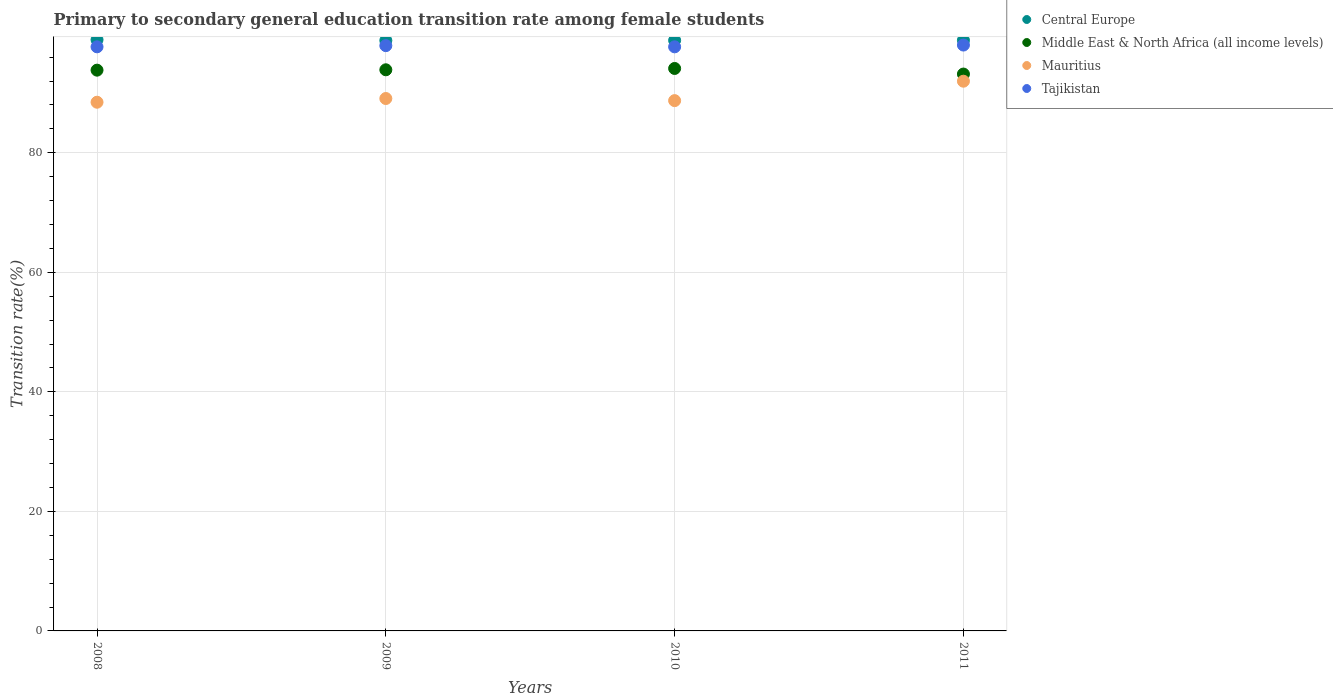How many different coloured dotlines are there?
Offer a terse response. 4. What is the transition rate in Central Europe in 2011?
Your answer should be very brief. 98.82. Across all years, what is the maximum transition rate in Middle East & North Africa (all income levels)?
Keep it short and to the point. 94.11. Across all years, what is the minimum transition rate in Tajikistan?
Offer a very short reply. 97.72. What is the total transition rate in Tajikistan in the graph?
Offer a terse response. 391.4. What is the difference between the transition rate in Tajikistan in 2008 and that in 2011?
Offer a very short reply. -0.3. What is the difference between the transition rate in Central Europe in 2009 and the transition rate in Mauritius in 2008?
Make the answer very short. 10.33. What is the average transition rate in Tajikistan per year?
Your answer should be very brief. 97.85. In the year 2008, what is the difference between the transition rate in Central Europe and transition rate in Tajikistan?
Make the answer very short. 1.19. What is the ratio of the transition rate in Middle East & North Africa (all income levels) in 2010 to that in 2011?
Keep it short and to the point. 1.01. What is the difference between the highest and the second highest transition rate in Tajikistan?
Make the answer very short. 0.1. What is the difference between the highest and the lowest transition rate in Central Europe?
Keep it short and to the point. 0.13. Does the transition rate in Mauritius monotonically increase over the years?
Give a very brief answer. No. Does the graph contain grids?
Ensure brevity in your answer.  Yes. Where does the legend appear in the graph?
Provide a succinct answer. Top right. How many legend labels are there?
Give a very brief answer. 4. What is the title of the graph?
Make the answer very short. Primary to secondary general education transition rate among female students. Does "Libya" appear as one of the legend labels in the graph?
Your answer should be very brief. No. What is the label or title of the Y-axis?
Ensure brevity in your answer.  Transition rate(%). What is the Transition rate(%) of Central Europe in 2008?
Make the answer very short. 98.92. What is the Transition rate(%) of Middle East & North Africa (all income levels) in 2008?
Your response must be concise. 93.82. What is the Transition rate(%) in Mauritius in 2008?
Offer a very short reply. 88.46. What is the Transition rate(%) of Tajikistan in 2008?
Your answer should be compact. 97.73. What is the Transition rate(%) of Central Europe in 2009?
Ensure brevity in your answer.  98.78. What is the Transition rate(%) in Middle East & North Africa (all income levels) in 2009?
Offer a very short reply. 93.88. What is the Transition rate(%) of Mauritius in 2009?
Provide a short and direct response. 89.08. What is the Transition rate(%) of Tajikistan in 2009?
Ensure brevity in your answer.  97.92. What is the Transition rate(%) of Central Europe in 2010?
Offer a very short reply. 98.81. What is the Transition rate(%) of Middle East & North Africa (all income levels) in 2010?
Ensure brevity in your answer.  94.11. What is the Transition rate(%) in Mauritius in 2010?
Your answer should be very brief. 88.72. What is the Transition rate(%) of Tajikistan in 2010?
Make the answer very short. 97.72. What is the Transition rate(%) of Central Europe in 2011?
Your answer should be compact. 98.82. What is the Transition rate(%) in Middle East & North Africa (all income levels) in 2011?
Keep it short and to the point. 93.17. What is the Transition rate(%) of Mauritius in 2011?
Offer a very short reply. 91.97. What is the Transition rate(%) of Tajikistan in 2011?
Your answer should be very brief. 98.02. Across all years, what is the maximum Transition rate(%) of Central Europe?
Offer a very short reply. 98.92. Across all years, what is the maximum Transition rate(%) in Middle East & North Africa (all income levels)?
Your answer should be compact. 94.11. Across all years, what is the maximum Transition rate(%) in Mauritius?
Ensure brevity in your answer.  91.97. Across all years, what is the maximum Transition rate(%) of Tajikistan?
Ensure brevity in your answer.  98.02. Across all years, what is the minimum Transition rate(%) in Central Europe?
Your response must be concise. 98.78. Across all years, what is the minimum Transition rate(%) in Middle East & North Africa (all income levels)?
Make the answer very short. 93.17. Across all years, what is the minimum Transition rate(%) in Mauritius?
Offer a very short reply. 88.46. Across all years, what is the minimum Transition rate(%) of Tajikistan?
Offer a very short reply. 97.72. What is the total Transition rate(%) of Central Europe in the graph?
Keep it short and to the point. 395.33. What is the total Transition rate(%) of Middle East & North Africa (all income levels) in the graph?
Your answer should be compact. 374.98. What is the total Transition rate(%) of Mauritius in the graph?
Offer a terse response. 358.24. What is the total Transition rate(%) of Tajikistan in the graph?
Offer a very short reply. 391.4. What is the difference between the Transition rate(%) in Central Europe in 2008 and that in 2009?
Provide a succinct answer. 0.13. What is the difference between the Transition rate(%) of Middle East & North Africa (all income levels) in 2008 and that in 2009?
Offer a terse response. -0.06. What is the difference between the Transition rate(%) in Mauritius in 2008 and that in 2009?
Ensure brevity in your answer.  -0.62. What is the difference between the Transition rate(%) of Tajikistan in 2008 and that in 2009?
Ensure brevity in your answer.  -0.2. What is the difference between the Transition rate(%) of Central Europe in 2008 and that in 2010?
Offer a very short reply. 0.11. What is the difference between the Transition rate(%) of Middle East & North Africa (all income levels) in 2008 and that in 2010?
Your answer should be very brief. -0.28. What is the difference between the Transition rate(%) in Mauritius in 2008 and that in 2010?
Your response must be concise. -0.27. What is the difference between the Transition rate(%) of Tajikistan in 2008 and that in 2010?
Keep it short and to the point. 0. What is the difference between the Transition rate(%) of Central Europe in 2008 and that in 2011?
Your answer should be compact. 0.09. What is the difference between the Transition rate(%) of Middle East & North Africa (all income levels) in 2008 and that in 2011?
Your answer should be compact. 0.65. What is the difference between the Transition rate(%) of Mauritius in 2008 and that in 2011?
Your answer should be very brief. -3.52. What is the difference between the Transition rate(%) of Tajikistan in 2008 and that in 2011?
Offer a very short reply. -0.3. What is the difference between the Transition rate(%) in Central Europe in 2009 and that in 2010?
Keep it short and to the point. -0.02. What is the difference between the Transition rate(%) of Middle East & North Africa (all income levels) in 2009 and that in 2010?
Provide a succinct answer. -0.22. What is the difference between the Transition rate(%) of Mauritius in 2009 and that in 2010?
Give a very brief answer. 0.35. What is the difference between the Transition rate(%) in Tajikistan in 2009 and that in 2010?
Keep it short and to the point. 0.2. What is the difference between the Transition rate(%) of Central Europe in 2009 and that in 2011?
Your answer should be compact. -0.04. What is the difference between the Transition rate(%) of Middle East & North Africa (all income levels) in 2009 and that in 2011?
Make the answer very short. 0.71. What is the difference between the Transition rate(%) in Mauritius in 2009 and that in 2011?
Make the answer very short. -2.9. What is the difference between the Transition rate(%) of Tajikistan in 2009 and that in 2011?
Make the answer very short. -0.1. What is the difference between the Transition rate(%) of Central Europe in 2010 and that in 2011?
Your response must be concise. -0.02. What is the difference between the Transition rate(%) of Middle East & North Africa (all income levels) in 2010 and that in 2011?
Offer a terse response. 0.94. What is the difference between the Transition rate(%) in Mauritius in 2010 and that in 2011?
Provide a succinct answer. -3.25. What is the difference between the Transition rate(%) of Tajikistan in 2010 and that in 2011?
Ensure brevity in your answer.  -0.3. What is the difference between the Transition rate(%) in Central Europe in 2008 and the Transition rate(%) in Middle East & North Africa (all income levels) in 2009?
Keep it short and to the point. 5.03. What is the difference between the Transition rate(%) of Central Europe in 2008 and the Transition rate(%) of Mauritius in 2009?
Ensure brevity in your answer.  9.84. What is the difference between the Transition rate(%) of Central Europe in 2008 and the Transition rate(%) of Tajikistan in 2009?
Provide a succinct answer. 0.99. What is the difference between the Transition rate(%) in Middle East & North Africa (all income levels) in 2008 and the Transition rate(%) in Mauritius in 2009?
Provide a short and direct response. 4.74. What is the difference between the Transition rate(%) of Middle East & North Africa (all income levels) in 2008 and the Transition rate(%) of Tajikistan in 2009?
Your answer should be compact. -4.1. What is the difference between the Transition rate(%) of Mauritius in 2008 and the Transition rate(%) of Tajikistan in 2009?
Offer a very short reply. -9.47. What is the difference between the Transition rate(%) of Central Europe in 2008 and the Transition rate(%) of Middle East & North Africa (all income levels) in 2010?
Give a very brief answer. 4.81. What is the difference between the Transition rate(%) in Central Europe in 2008 and the Transition rate(%) in Mauritius in 2010?
Offer a very short reply. 10.19. What is the difference between the Transition rate(%) in Central Europe in 2008 and the Transition rate(%) in Tajikistan in 2010?
Provide a succinct answer. 1.19. What is the difference between the Transition rate(%) of Middle East & North Africa (all income levels) in 2008 and the Transition rate(%) of Mauritius in 2010?
Your response must be concise. 5.1. What is the difference between the Transition rate(%) of Middle East & North Africa (all income levels) in 2008 and the Transition rate(%) of Tajikistan in 2010?
Your response must be concise. -3.9. What is the difference between the Transition rate(%) in Mauritius in 2008 and the Transition rate(%) in Tajikistan in 2010?
Make the answer very short. -9.27. What is the difference between the Transition rate(%) in Central Europe in 2008 and the Transition rate(%) in Middle East & North Africa (all income levels) in 2011?
Your response must be concise. 5.75. What is the difference between the Transition rate(%) in Central Europe in 2008 and the Transition rate(%) in Mauritius in 2011?
Ensure brevity in your answer.  6.94. What is the difference between the Transition rate(%) of Central Europe in 2008 and the Transition rate(%) of Tajikistan in 2011?
Provide a succinct answer. 0.9. What is the difference between the Transition rate(%) of Middle East & North Africa (all income levels) in 2008 and the Transition rate(%) of Mauritius in 2011?
Make the answer very short. 1.85. What is the difference between the Transition rate(%) in Middle East & North Africa (all income levels) in 2008 and the Transition rate(%) in Tajikistan in 2011?
Provide a succinct answer. -4.2. What is the difference between the Transition rate(%) in Mauritius in 2008 and the Transition rate(%) in Tajikistan in 2011?
Your response must be concise. -9.57. What is the difference between the Transition rate(%) of Central Europe in 2009 and the Transition rate(%) of Middle East & North Africa (all income levels) in 2010?
Provide a succinct answer. 4.68. What is the difference between the Transition rate(%) of Central Europe in 2009 and the Transition rate(%) of Mauritius in 2010?
Make the answer very short. 10.06. What is the difference between the Transition rate(%) in Central Europe in 2009 and the Transition rate(%) in Tajikistan in 2010?
Make the answer very short. 1.06. What is the difference between the Transition rate(%) in Middle East & North Africa (all income levels) in 2009 and the Transition rate(%) in Mauritius in 2010?
Make the answer very short. 5.16. What is the difference between the Transition rate(%) of Middle East & North Africa (all income levels) in 2009 and the Transition rate(%) of Tajikistan in 2010?
Offer a very short reply. -3.84. What is the difference between the Transition rate(%) in Mauritius in 2009 and the Transition rate(%) in Tajikistan in 2010?
Provide a short and direct response. -8.65. What is the difference between the Transition rate(%) of Central Europe in 2009 and the Transition rate(%) of Middle East & North Africa (all income levels) in 2011?
Your response must be concise. 5.61. What is the difference between the Transition rate(%) in Central Europe in 2009 and the Transition rate(%) in Mauritius in 2011?
Keep it short and to the point. 6.81. What is the difference between the Transition rate(%) in Central Europe in 2009 and the Transition rate(%) in Tajikistan in 2011?
Provide a succinct answer. 0.76. What is the difference between the Transition rate(%) in Middle East & North Africa (all income levels) in 2009 and the Transition rate(%) in Mauritius in 2011?
Keep it short and to the point. 1.91. What is the difference between the Transition rate(%) of Middle East & North Africa (all income levels) in 2009 and the Transition rate(%) of Tajikistan in 2011?
Your answer should be compact. -4.14. What is the difference between the Transition rate(%) of Mauritius in 2009 and the Transition rate(%) of Tajikistan in 2011?
Offer a terse response. -8.94. What is the difference between the Transition rate(%) of Central Europe in 2010 and the Transition rate(%) of Middle East & North Africa (all income levels) in 2011?
Offer a terse response. 5.64. What is the difference between the Transition rate(%) in Central Europe in 2010 and the Transition rate(%) in Mauritius in 2011?
Keep it short and to the point. 6.83. What is the difference between the Transition rate(%) of Central Europe in 2010 and the Transition rate(%) of Tajikistan in 2011?
Keep it short and to the point. 0.78. What is the difference between the Transition rate(%) in Middle East & North Africa (all income levels) in 2010 and the Transition rate(%) in Mauritius in 2011?
Offer a terse response. 2.13. What is the difference between the Transition rate(%) in Middle East & North Africa (all income levels) in 2010 and the Transition rate(%) in Tajikistan in 2011?
Make the answer very short. -3.92. What is the difference between the Transition rate(%) in Mauritius in 2010 and the Transition rate(%) in Tajikistan in 2011?
Offer a terse response. -9.3. What is the average Transition rate(%) in Central Europe per year?
Provide a succinct answer. 98.83. What is the average Transition rate(%) in Middle East & North Africa (all income levels) per year?
Your answer should be compact. 93.75. What is the average Transition rate(%) in Mauritius per year?
Offer a terse response. 89.56. What is the average Transition rate(%) of Tajikistan per year?
Ensure brevity in your answer.  97.85. In the year 2008, what is the difference between the Transition rate(%) of Central Europe and Transition rate(%) of Middle East & North Africa (all income levels)?
Offer a very short reply. 5.1. In the year 2008, what is the difference between the Transition rate(%) in Central Europe and Transition rate(%) in Mauritius?
Make the answer very short. 10.46. In the year 2008, what is the difference between the Transition rate(%) of Central Europe and Transition rate(%) of Tajikistan?
Make the answer very short. 1.19. In the year 2008, what is the difference between the Transition rate(%) of Middle East & North Africa (all income levels) and Transition rate(%) of Mauritius?
Provide a short and direct response. 5.37. In the year 2008, what is the difference between the Transition rate(%) of Middle East & North Africa (all income levels) and Transition rate(%) of Tajikistan?
Your answer should be compact. -3.9. In the year 2008, what is the difference between the Transition rate(%) of Mauritius and Transition rate(%) of Tajikistan?
Offer a terse response. -9.27. In the year 2009, what is the difference between the Transition rate(%) of Central Europe and Transition rate(%) of Middle East & North Africa (all income levels)?
Give a very brief answer. 4.9. In the year 2009, what is the difference between the Transition rate(%) in Central Europe and Transition rate(%) in Mauritius?
Offer a very short reply. 9.71. In the year 2009, what is the difference between the Transition rate(%) of Central Europe and Transition rate(%) of Tajikistan?
Make the answer very short. 0.86. In the year 2009, what is the difference between the Transition rate(%) in Middle East & North Africa (all income levels) and Transition rate(%) in Mauritius?
Offer a very short reply. 4.81. In the year 2009, what is the difference between the Transition rate(%) in Middle East & North Africa (all income levels) and Transition rate(%) in Tajikistan?
Offer a terse response. -4.04. In the year 2009, what is the difference between the Transition rate(%) of Mauritius and Transition rate(%) of Tajikistan?
Keep it short and to the point. -8.85. In the year 2010, what is the difference between the Transition rate(%) in Central Europe and Transition rate(%) in Middle East & North Africa (all income levels)?
Give a very brief answer. 4.7. In the year 2010, what is the difference between the Transition rate(%) in Central Europe and Transition rate(%) in Mauritius?
Offer a very short reply. 10.08. In the year 2010, what is the difference between the Transition rate(%) in Central Europe and Transition rate(%) in Tajikistan?
Give a very brief answer. 1.08. In the year 2010, what is the difference between the Transition rate(%) of Middle East & North Africa (all income levels) and Transition rate(%) of Mauritius?
Your answer should be compact. 5.38. In the year 2010, what is the difference between the Transition rate(%) in Middle East & North Africa (all income levels) and Transition rate(%) in Tajikistan?
Ensure brevity in your answer.  -3.62. In the year 2011, what is the difference between the Transition rate(%) of Central Europe and Transition rate(%) of Middle East & North Africa (all income levels)?
Your answer should be very brief. 5.65. In the year 2011, what is the difference between the Transition rate(%) of Central Europe and Transition rate(%) of Mauritius?
Keep it short and to the point. 6.85. In the year 2011, what is the difference between the Transition rate(%) in Central Europe and Transition rate(%) in Tajikistan?
Your response must be concise. 0.8. In the year 2011, what is the difference between the Transition rate(%) of Middle East & North Africa (all income levels) and Transition rate(%) of Mauritius?
Offer a terse response. 1.2. In the year 2011, what is the difference between the Transition rate(%) of Middle East & North Africa (all income levels) and Transition rate(%) of Tajikistan?
Your answer should be very brief. -4.85. In the year 2011, what is the difference between the Transition rate(%) in Mauritius and Transition rate(%) in Tajikistan?
Your answer should be compact. -6.05. What is the ratio of the Transition rate(%) of Middle East & North Africa (all income levels) in 2008 to that in 2009?
Make the answer very short. 1. What is the ratio of the Transition rate(%) in Mauritius in 2008 to that in 2009?
Provide a short and direct response. 0.99. What is the ratio of the Transition rate(%) in Central Europe in 2008 to that in 2010?
Your answer should be compact. 1. What is the ratio of the Transition rate(%) of Middle East & North Africa (all income levels) in 2008 to that in 2010?
Provide a succinct answer. 1. What is the ratio of the Transition rate(%) in Mauritius in 2008 to that in 2011?
Make the answer very short. 0.96. What is the ratio of the Transition rate(%) in Central Europe in 2009 to that in 2010?
Your response must be concise. 1. What is the ratio of the Transition rate(%) of Central Europe in 2009 to that in 2011?
Offer a terse response. 1. What is the ratio of the Transition rate(%) of Middle East & North Africa (all income levels) in 2009 to that in 2011?
Make the answer very short. 1.01. What is the ratio of the Transition rate(%) of Mauritius in 2009 to that in 2011?
Your answer should be compact. 0.97. What is the ratio of the Transition rate(%) in Middle East & North Africa (all income levels) in 2010 to that in 2011?
Your answer should be compact. 1.01. What is the ratio of the Transition rate(%) in Mauritius in 2010 to that in 2011?
Provide a succinct answer. 0.96. What is the difference between the highest and the second highest Transition rate(%) of Central Europe?
Your answer should be very brief. 0.09. What is the difference between the highest and the second highest Transition rate(%) of Middle East & North Africa (all income levels)?
Provide a short and direct response. 0.22. What is the difference between the highest and the second highest Transition rate(%) of Mauritius?
Offer a terse response. 2.9. What is the difference between the highest and the second highest Transition rate(%) of Tajikistan?
Your answer should be compact. 0.1. What is the difference between the highest and the lowest Transition rate(%) in Central Europe?
Provide a succinct answer. 0.13. What is the difference between the highest and the lowest Transition rate(%) in Middle East & North Africa (all income levels)?
Offer a very short reply. 0.94. What is the difference between the highest and the lowest Transition rate(%) in Mauritius?
Your answer should be compact. 3.52. What is the difference between the highest and the lowest Transition rate(%) in Tajikistan?
Provide a succinct answer. 0.3. 